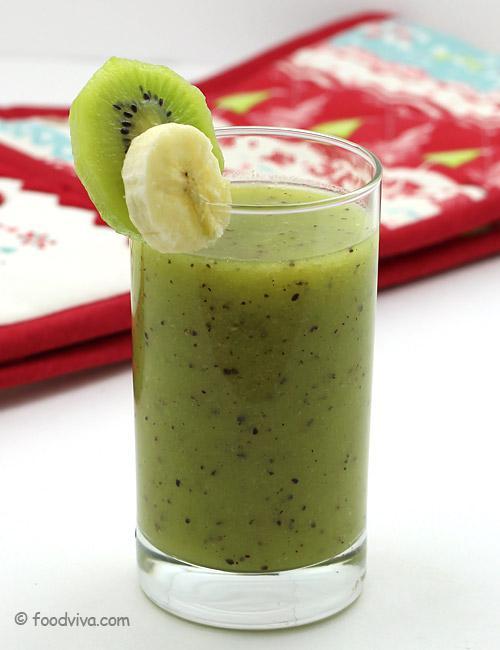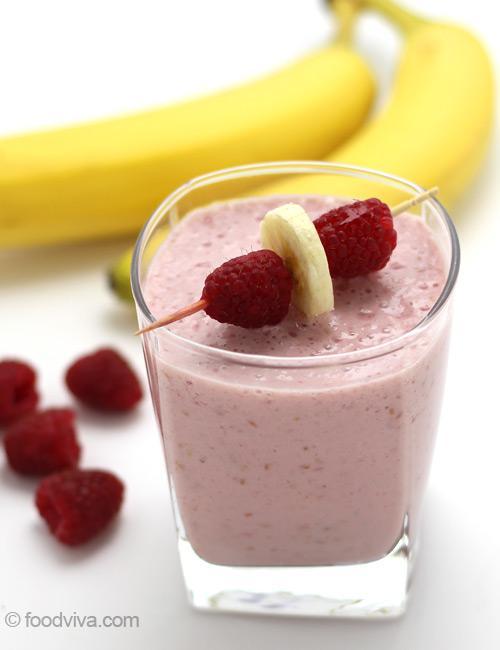The first image is the image on the left, the second image is the image on the right. Given the left and right images, does the statement "One image shows chopped kiwi fruit, banana chunks, and lemon juice, while the second image includes a prepared green smoothie and cut kiwi fruit." hold true? Answer yes or no. No. The first image is the image on the left, the second image is the image on the right. Given the left and right images, does the statement "A glass containing a speckled green beverage is garnished with a kiwi fruit slice." hold true? Answer yes or no. Yes. 